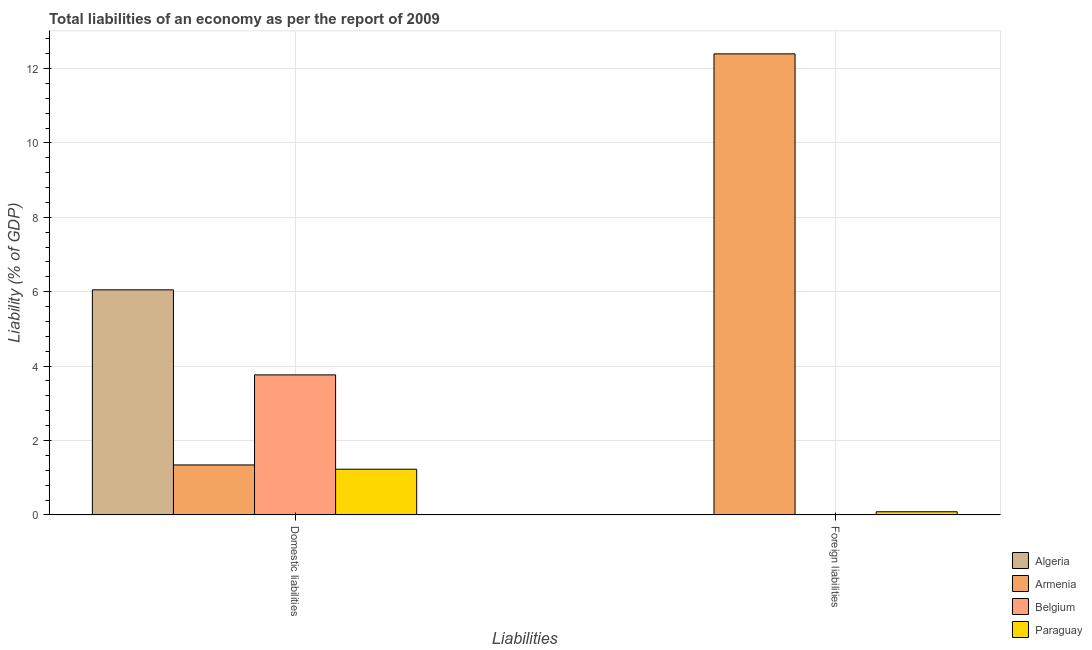How many groups of bars are there?
Ensure brevity in your answer.  2. Are the number of bars per tick equal to the number of legend labels?
Provide a succinct answer. No. Are the number of bars on each tick of the X-axis equal?
Your answer should be compact. No. How many bars are there on the 1st tick from the right?
Keep it short and to the point. 2. What is the label of the 1st group of bars from the left?
Provide a short and direct response. Domestic liabilities. Across all countries, what is the maximum incurrence of foreign liabilities?
Offer a very short reply. 12.39. Across all countries, what is the minimum incurrence of domestic liabilities?
Ensure brevity in your answer.  1.23. In which country was the incurrence of domestic liabilities maximum?
Keep it short and to the point. Algeria. What is the total incurrence of foreign liabilities in the graph?
Give a very brief answer. 12.48. What is the difference between the incurrence of domestic liabilities in Belgium and that in Algeria?
Provide a succinct answer. -2.29. What is the difference between the incurrence of domestic liabilities in Belgium and the incurrence of foreign liabilities in Algeria?
Offer a terse response. 3.76. What is the average incurrence of foreign liabilities per country?
Provide a short and direct response. 3.12. What is the difference between the incurrence of domestic liabilities and incurrence of foreign liabilities in Armenia?
Give a very brief answer. -11.05. What is the ratio of the incurrence of foreign liabilities in Paraguay to that in Armenia?
Make the answer very short. 0.01. How many bars are there?
Offer a terse response. 6. How many countries are there in the graph?
Keep it short and to the point. 4. Does the graph contain grids?
Your answer should be compact. Yes. What is the title of the graph?
Your answer should be very brief. Total liabilities of an economy as per the report of 2009. What is the label or title of the X-axis?
Your answer should be very brief. Liabilities. What is the label or title of the Y-axis?
Ensure brevity in your answer.  Liability (% of GDP). What is the Liability (% of GDP) of Algeria in Domestic liabilities?
Your response must be concise. 6.05. What is the Liability (% of GDP) in Armenia in Domestic liabilities?
Keep it short and to the point. 1.34. What is the Liability (% of GDP) of Belgium in Domestic liabilities?
Make the answer very short. 3.76. What is the Liability (% of GDP) in Paraguay in Domestic liabilities?
Make the answer very short. 1.23. What is the Liability (% of GDP) of Algeria in Foreign liabilities?
Offer a terse response. 0. What is the Liability (% of GDP) in Armenia in Foreign liabilities?
Provide a succinct answer. 12.39. What is the Liability (% of GDP) in Paraguay in Foreign liabilities?
Give a very brief answer. 0.09. Across all Liabilities, what is the maximum Liability (% of GDP) in Algeria?
Give a very brief answer. 6.05. Across all Liabilities, what is the maximum Liability (% of GDP) of Armenia?
Make the answer very short. 12.39. Across all Liabilities, what is the maximum Liability (% of GDP) in Belgium?
Give a very brief answer. 3.76. Across all Liabilities, what is the maximum Liability (% of GDP) of Paraguay?
Keep it short and to the point. 1.23. Across all Liabilities, what is the minimum Liability (% of GDP) in Armenia?
Give a very brief answer. 1.34. Across all Liabilities, what is the minimum Liability (% of GDP) in Paraguay?
Offer a very short reply. 0.09. What is the total Liability (% of GDP) in Algeria in the graph?
Your response must be concise. 6.05. What is the total Liability (% of GDP) in Armenia in the graph?
Your response must be concise. 13.74. What is the total Liability (% of GDP) in Belgium in the graph?
Your answer should be very brief. 3.76. What is the total Liability (% of GDP) of Paraguay in the graph?
Ensure brevity in your answer.  1.31. What is the difference between the Liability (% of GDP) in Armenia in Domestic liabilities and that in Foreign liabilities?
Keep it short and to the point. -11.05. What is the difference between the Liability (% of GDP) of Paraguay in Domestic liabilities and that in Foreign liabilities?
Your answer should be compact. 1.14. What is the difference between the Liability (% of GDP) of Algeria in Domestic liabilities and the Liability (% of GDP) of Armenia in Foreign liabilities?
Give a very brief answer. -6.34. What is the difference between the Liability (% of GDP) of Algeria in Domestic liabilities and the Liability (% of GDP) of Paraguay in Foreign liabilities?
Provide a succinct answer. 5.96. What is the difference between the Liability (% of GDP) of Armenia in Domestic liabilities and the Liability (% of GDP) of Paraguay in Foreign liabilities?
Give a very brief answer. 1.26. What is the difference between the Liability (% of GDP) of Belgium in Domestic liabilities and the Liability (% of GDP) of Paraguay in Foreign liabilities?
Make the answer very short. 3.68. What is the average Liability (% of GDP) in Algeria per Liabilities?
Offer a terse response. 3.03. What is the average Liability (% of GDP) in Armenia per Liabilities?
Give a very brief answer. 6.87. What is the average Liability (% of GDP) in Belgium per Liabilities?
Provide a succinct answer. 1.88. What is the average Liability (% of GDP) in Paraguay per Liabilities?
Your answer should be very brief. 0.66. What is the difference between the Liability (% of GDP) in Algeria and Liability (% of GDP) in Armenia in Domestic liabilities?
Offer a terse response. 4.71. What is the difference between the Liability (% of GDP) in Algeria and Liability (% of GDP) in Belgium in Domestic liabilities?
Keep it short and to the point. 2.29. What is the difference between the Liability (% of GDP) of Algeria and Liability (% of GDP) of Paraguay in Domestic liabilities?
Your answer should be compact. 4.82. What is the difference between the Liability (% of GDP) of Armenia and Liability (% of GDP) of Belgium in Domestic liabilities?
Your response must be concise. -2.42. What is the difference between the Liability (% of GDP) of Armenia and Liability (% of GDP) of Paraguay in Domestic liabilities?
Provide a succinct answer. 0.11. What is the difference between the Liability (% of GDP) of Belgium and Liability (% of GDP) of Paraguay in Domestic liabilities?
Keep it short and to the point. 2.54. What is the difference between the Liability (% of GDP) in Armenia and Liability (% of GDP) in Paraguay in Foreign liabilities?
Keep it short and to the point. 12.31. What is the ratio of the Liability (% of GDP) of Armenia in Domestic liabilities to that in Foreign liabilities?
Ensure brevity in your answer.  0.11. What is the ratio of the Liability (% of GDP) in Paraguay in Domestic liabilities to that in Foreign liabilities?
Offer a terse response. 14.41. What is the difference between the highest and the second highest Liability (% of GDP) of Armenia?
Ensure brevity in your answer.  11.05. What is the difference between the highest and the second highest Liability (% of GDP) in Paraguay?
Give a very brief answer. 1.14. What is the difference between the highest and the lowest Liability (% of GDP) in Algeria?
Offer a terse response. 6.05. What is the difference between the highest and the lowest Liability (% of GDP) of Armenia?
Your response must be concise. 11.05. What is the difference between the highest and the lowest Liability (% of GDP) in Belgium?
Your response must be concise. 3.76. What is the difference between the highest and the lowest Liability (% of GDP) of Paraguay?
Give a very brief answer. 1.14. 